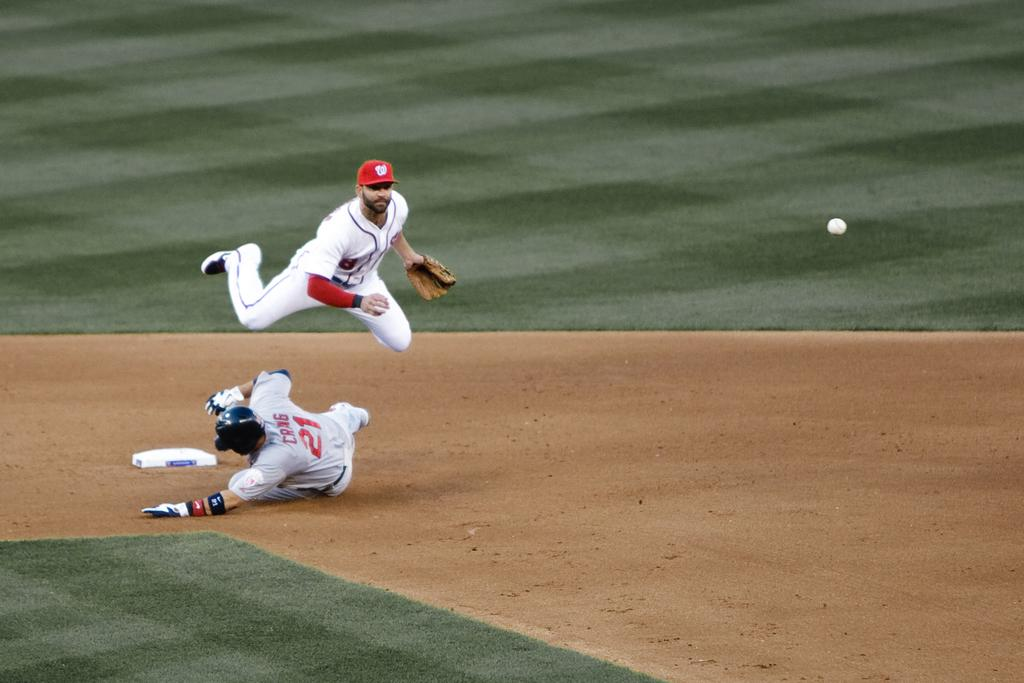<image>
Write a terse but informative summary of the picture. A baseball player with the number 21 on his jersey is sliding to base while another one jumps in the air. 